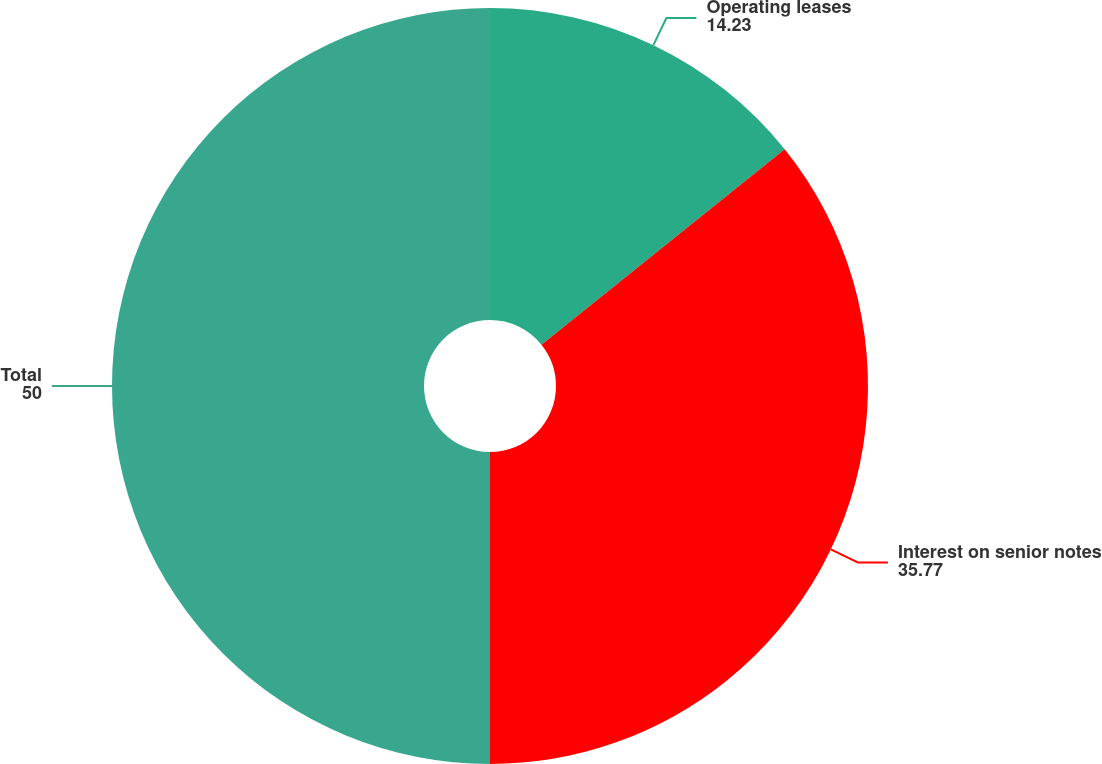Convert chart. <chart><loc_0><loc_0><loc_500><loc_500><pie_chart><fcel>Operating leases<fcel>Interest on senior notes<fcel>Total<nl><fcel>14.23%<fcel>35.77%<fcel>50.0%<nl></chart> 